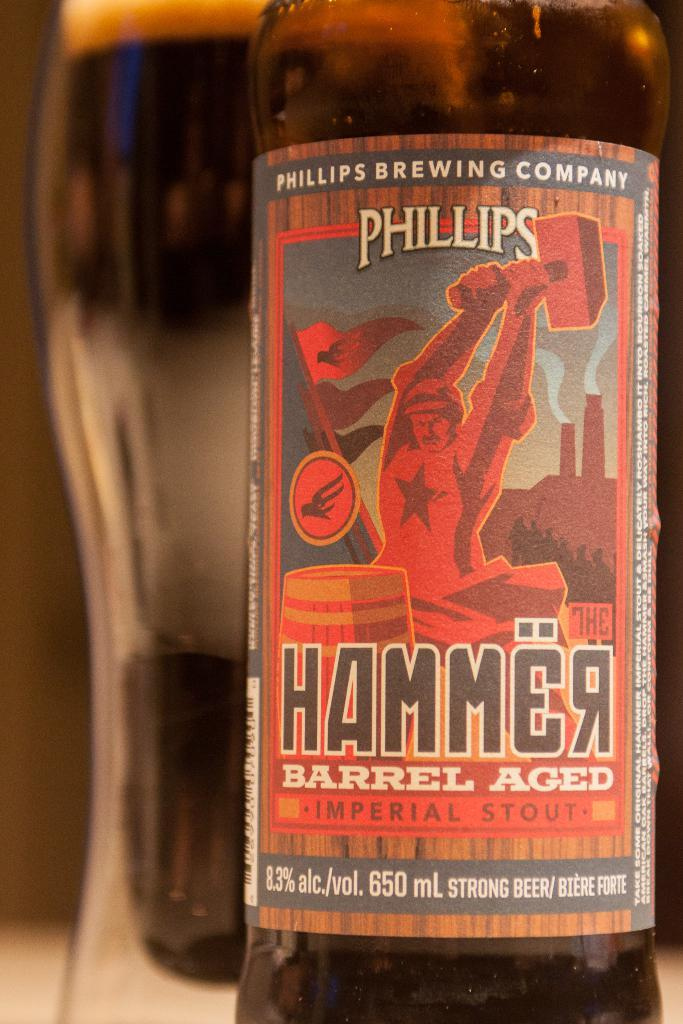<image>
Write a terse but informative summary of the picture. the word Hammer is on the beer item 